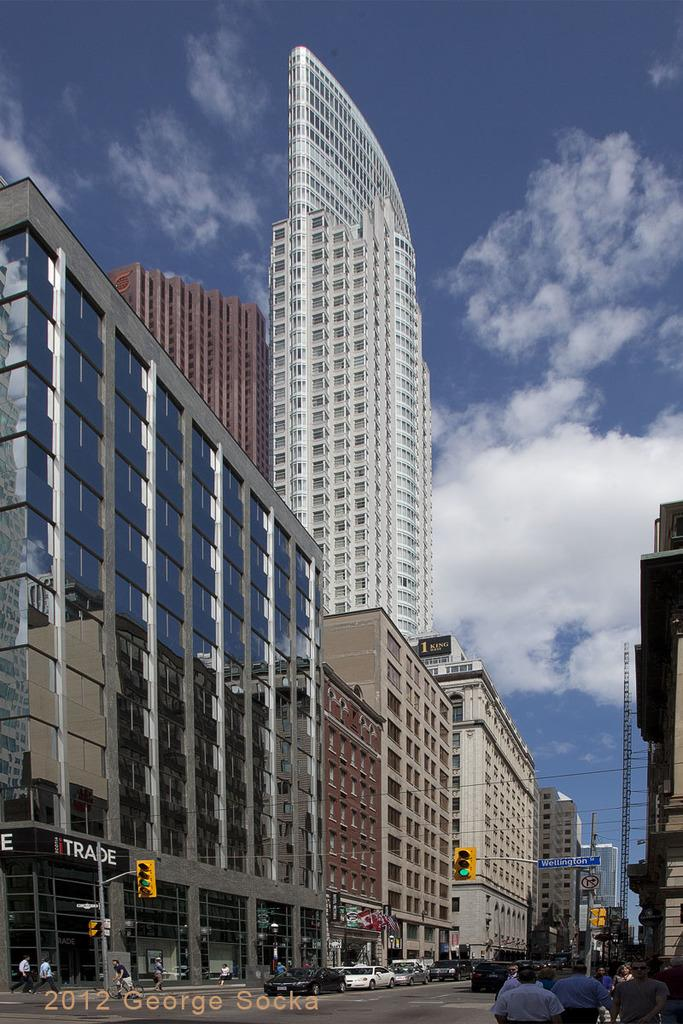What can be seen at the bottom of the image? There are traffic signals at the bottom of the image. What is happening in the middle of the image? There are parked cars on the road in the middle of the image. What type of structures are visible in the image? There are buildings visible in the image. How would you describe the sky in the image? The sky is cloudy at the top of the image. Can you tell me how many spots are on the traffic signals in the image? There are no spots mentioned or visible on the traffic signals in the image. What decision is being made by the parked cars in the image? The parked cars are not making any decisions, as they are inanimate objects. 